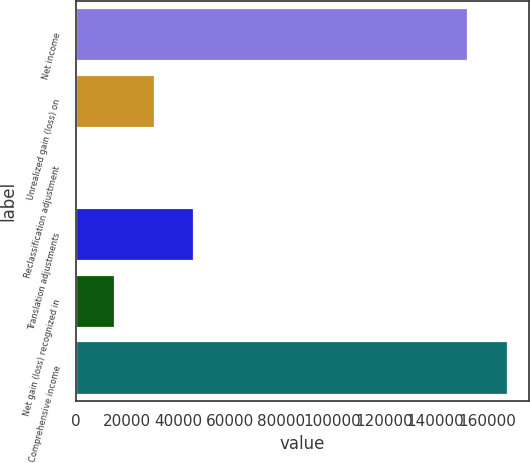<chart> <loc_0><loc_0><loc_500><loc_500><bar_chart><fcel>Net income<fcel>Unrealized gain (loss) on<fcel>Reclassification adjustment<fcel>Translation adjustments<fcel>Net gain (loss) recognized in<fcel>Comprehensive income<nl><fcel>152820<fcel>30723<fcel>51<fcel>46059<fcel>15387<fcel>168156<nl></chart> 